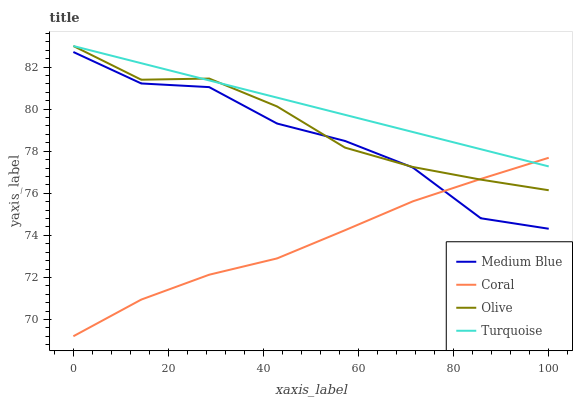Does Coral have the minimum area under the curve?
Answer yes or no. Yes. Does Turquoise have the maximum area under the curve?
Answer yes or no. Yes. Does Medium Blue have the minimum area under the curve?
Answer yes or no. No. Does Medium Blue have the maximum area under the curve?
Answer yes or no. No. Is Turquoise the smoothest?
Answer yes or no. Yes. Is Medium Blue the roughest?
Answer yes or no. Yes. Is Coral the smoothest?
Answer yes or no. No. Is Coral the roughest?
Answer yes or no. No. Does Coral have the lowest value?
Answer yes or no. Yes. Does Medium Blue have the lowest value?
Answer yes or no. No. Does Turquoise have the highest value?
Answer yes or no. Yes. Does Medium Blue have the highest value?
Answer yes or no. No. Is Medium Blue less than Turquoise?
Answer yes or no. Yes. Is Turquoise greater than Medium Blue?
Answer yes or no. Yes. Does Turquoise intersect Olive?
Answer yes or no. Yes. Is Turquoise less than Olive?
Answer yes or no. No. Is Turquoise greater than Olive?
Answer yes or no. No. Does Medium Blue intersect Turquoise?
Answer yes or no. No. 